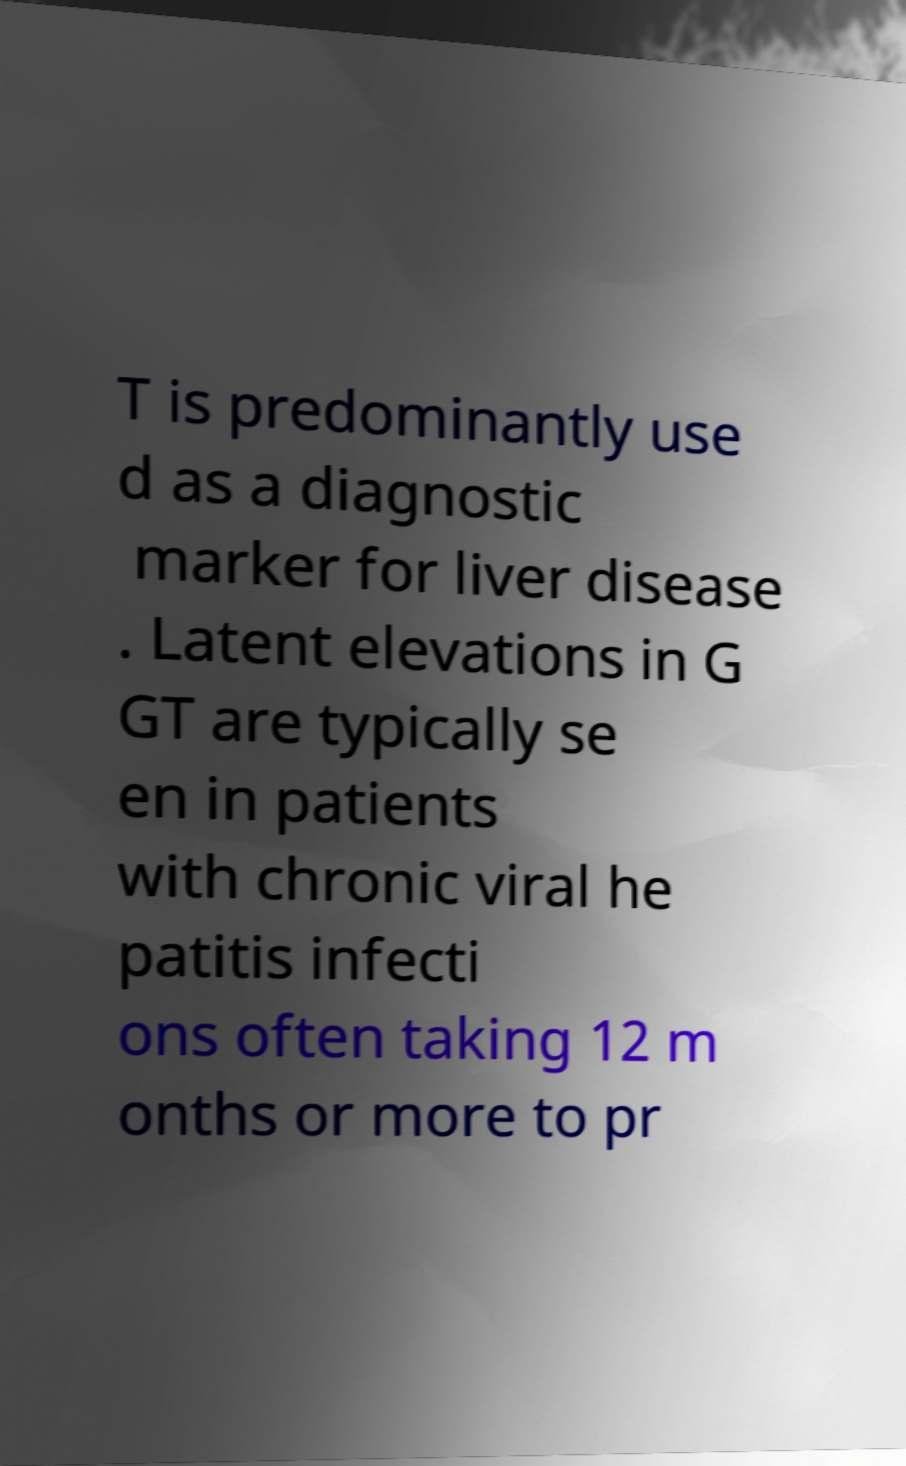Can you read and provide the text displayed in the image?This photo seems to have some interesting text. Can you extract and type it out for me? T is predominantly use d as a diagnostic marker for liver disease . Latent elevations in G GT are typically se en in patients with chronic viral he patitis infecti ons often taking 12 m onths or more to pr 